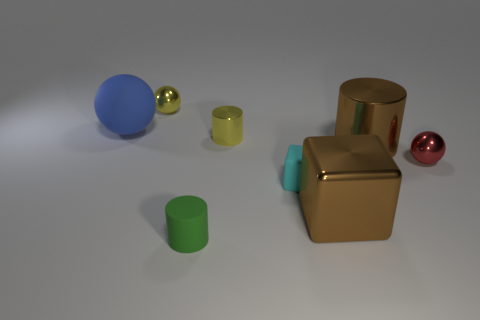There is a shiny object that is the same size as the metallic block; what color is it?
Ensure brevity in your answer.  Brown. Is there another large sphere that has the same color as the large ball?
Offer a terse response. No. How many things are either small shiny balls that are to the left of the tiny green rubber object or blue spheres?
Your answer should be very brief. 2. How many other objects are the same size as the yellow metal ball?
Offer a terse response. 4. The ball that is to the right of the yellow thing in front of the metal thing that is behind the blue matte ball is made of what material?
Provide a succinct answer. Metal. How many spheres are small rubber things or blue objects?
Your answer should be compact. 1. Is there anything else that is the same shape as the small cyan rubber thing?
Keep it short and to the point. Yes. Is the number of shiny things that are right of the small green rubber object greater than the number of shiny objects in front of the blue object?
Provide a succinct answer. No. There is a rubber object that is behind the big brown metal cylinder; what number of tiny yellow objects are behind it?
Your answer should be compact. 1. What number of things are either small yellow cylinders or yellow balls?
Provide a short and direct response. 2. 